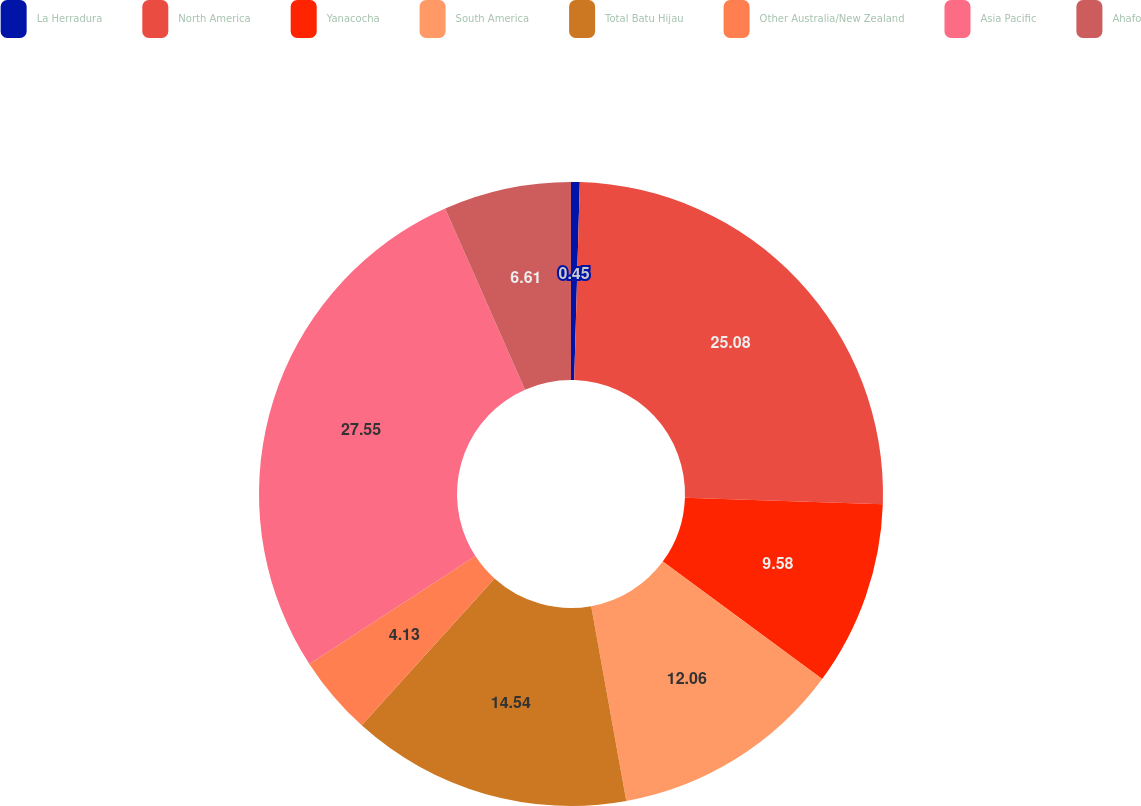<chart> <loc_0><loc_0><loc_500><loc_500><pie_chart><fcel>La Herradura<fcel>North America<fcel>Yanacocha<fcel>South America<fcel>Total Batu Hijau<fcel>Other Australia/New Zealand<fcel>Asia Pacific<fcel>Ahafo<nl><fcel>0.45%<fcel>25.08%<fcel>9.58%<fcel>12.06%<fcel>14.54%<fcel>4.13%<fcel>27.56%<fcel>6.61%<nl></chart> 